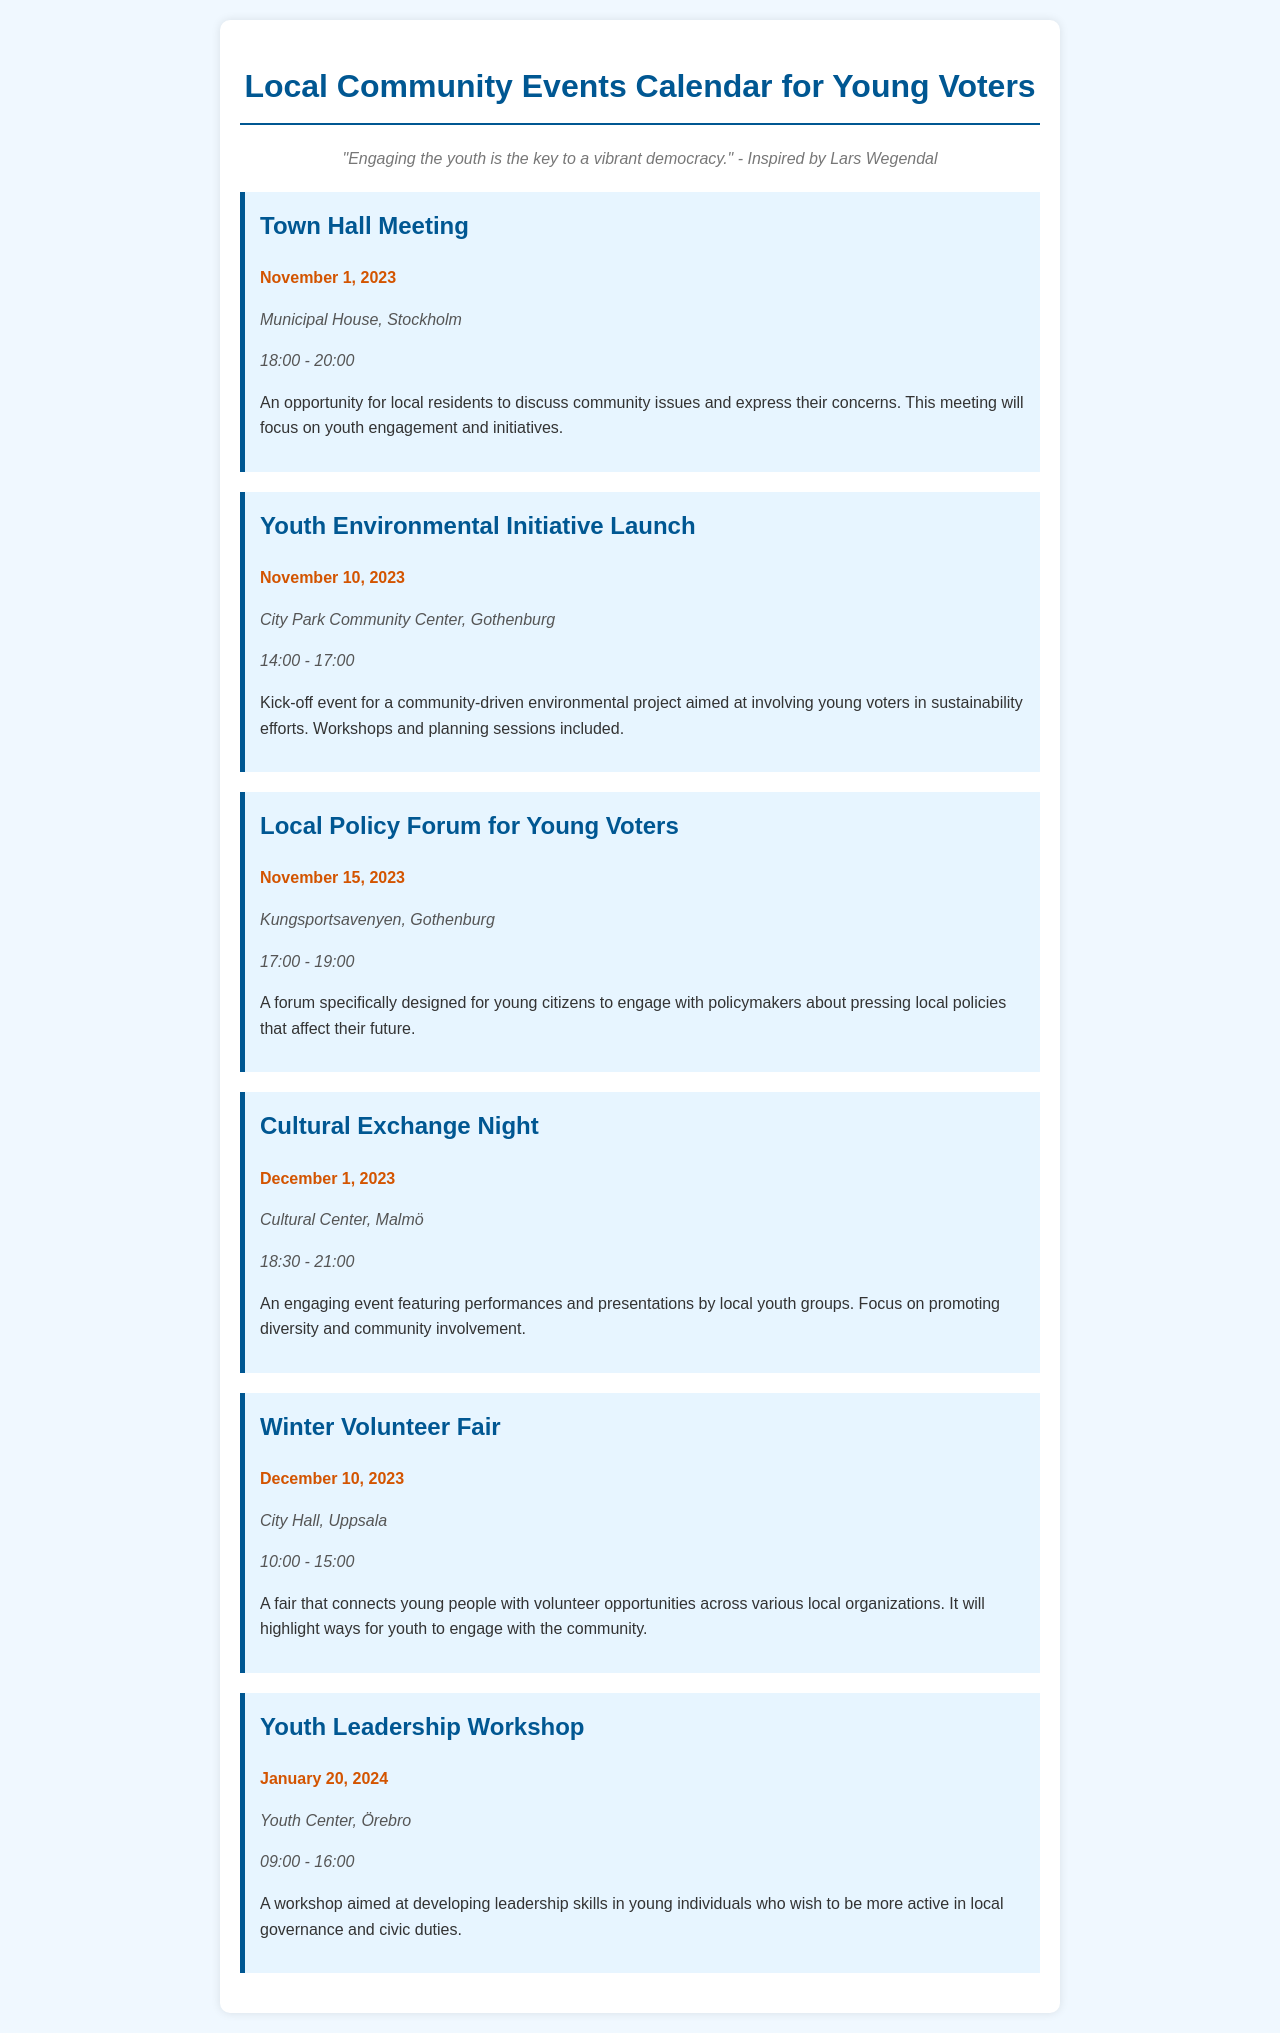What is the date of the Town Hall Meeting? The Town Hall Meeting is scheduled for November 1, 2023.
Answer: November 1, 2023 Where is the Youth Environmental Initiative Launch taking place? The Youth Environmental Initiative Launch will be at the City Park Community Center, Gothenburg.
Answer: City Park Community Center, Gothenburg What time does the Local Policy Forum for Young Voters start? The Local Policy Forum for Young Voters begins at 17:00.
Answer: 17:00 How many events are scheduled in December? There are two events scheduled for December, namely the Cultural Exchange Night and the Winter Volunteer Fair.
Answer: Two What is the main focus of the Cultural Exchange Night? The Cultural Exchange Night focuses on promoting diversity and community involvement through performances and presentations by local youth groups.
Answer: Promoting diversity and community involvement What is one of the main purposes of the Winter Volunteer Fair? The Winter Volunteer Fair aims to connect young people with volunteer opportunities across various local organizations.
Answer: Connect young people with volunteer opportunities What type of event will the Youth Leadership Workshop be classified as? The Youth Leadership Workshop is aimed at developing leadership skills in young individuals.
Answer: Leadership Workshop Which event has the latest date? The Youth Leadership Workshop on January 20, 2024 is the latest event.
Answer: January 20, 2024 